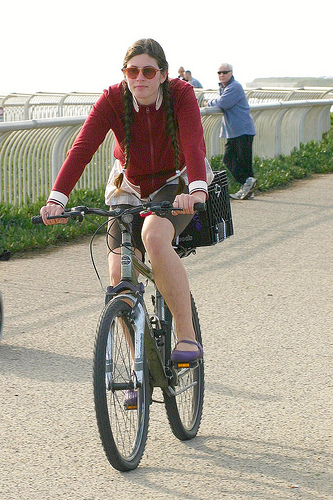<image>
Can you confirm if the women is on the bicycle? Yes. Looking at the image, I can see the women is positioned on top of the bicycle, with the bicycle providing support. Is there a man on the bicycle? No. The man is not positioned on the bicycle. They may be near each other, but the man is not supported by or resting on top of the bicycle. Is the person on the bike? No. The person is not positioned on the bike. They may be near each other, but the person is not supported by or resting on top of the bike. Where is the man in relation to the fence? Is it behind the fence? Yes. From this viewpoint, the man is positioned behind the fence, with the fence partially or fully occluding the man. Where is the woman in relation to the bike? Is it behind the bike? No. The woman is not behind the bike. From this viewpoint, the woman appears to be positioned elsewhere in the scene. 